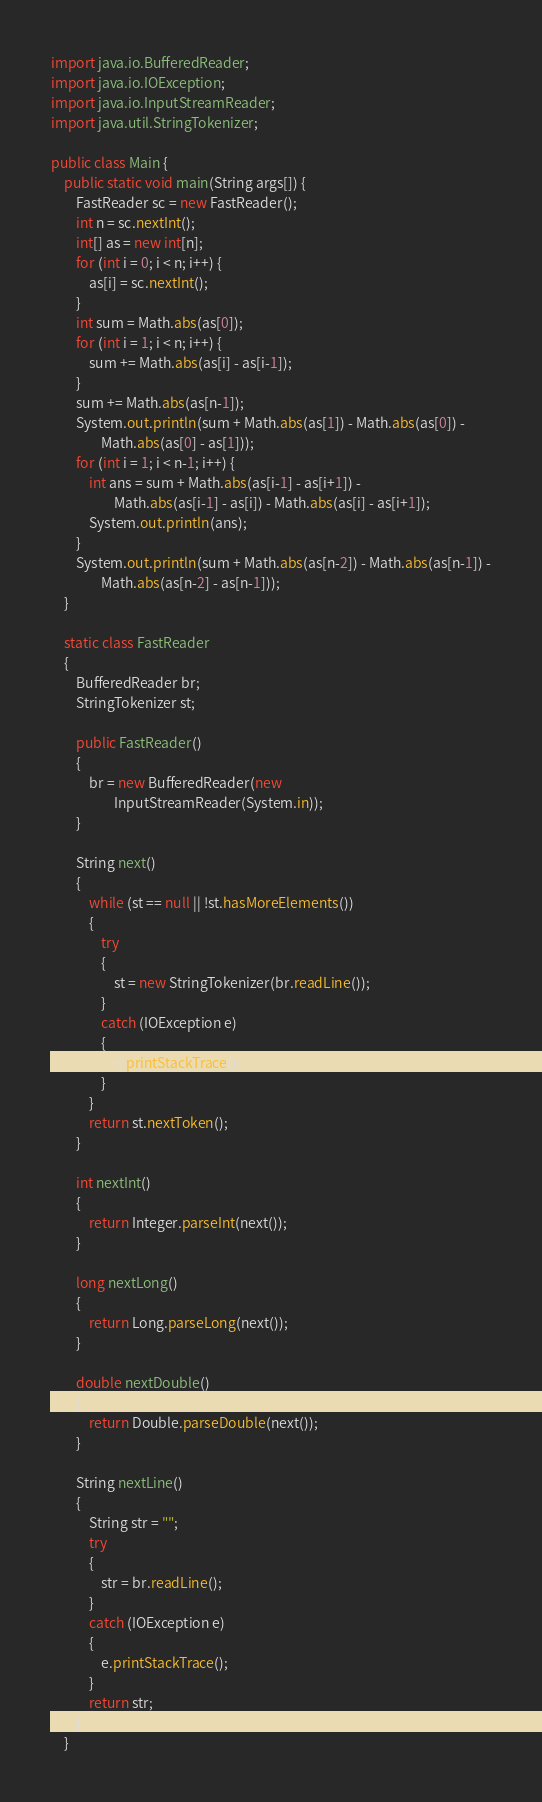Convert code to text. <code><loc_0><loc_0><loc_500><loc_500><_Java_>import java.io.BufferedReader;
import java.io.IOException;
import java.io.InputStreamReader;
import java.util.StringTokenizer;

public class Main {
    public static void main(String args[]) {
        FastReader sc = new FastReader();
        int n = sc.nextInt();
        int[] as = new int[n];
        for (int i = 0; i < n; i++) {
            as[i] = sc.nextInt();
        }
        int sum = Math.abs(as[0]);
        for (int i = 1; i < n; i++) {
            sum += Math.abs(as[i] - as[i-1]);
        }
        sum += Math.abs(as[n-1]);
        System.out.println(sum + Math.abs(as[1]) - Math.abs(as[0]) -
                Math.abs(as[0] - as[1]));
        for (int i = 1; i < n-1; i++) {
            int ans = sum + Math.abs(as[i-1] - as[i+1]) -
                    Math.abs(as[i-1] - as[i]) - Math.abs(as[i] - as[i+1]);
            System.out.println(ans);
        }
        System.out.println(sum + Math.abs(as[n-2]) - Math.abs(as[n-1]) -
                Math.abs(as[n-2] - as[n-1]));
    }

    static class FastReader
    {
        BufferedReader br;
        StringTokenizer st;

        public FastReader()
        {
            br = new BufferedReader(new
                    InputStreamReader(System.in));
        }

        String next()
        {
            while (st == null || !st.hasMoreElements())
            {
                try
                {
                    st = new StringTokenizer(br.readLine());
                }
                catch (IOException e)
                {
                    e.printStackTrace();
                }
            }
            return st.nextToken();
        }

        int nextInt()
        {
            return Integer.parseInt(next());
        }

        long nextLong()
        {
            return Long.parseLong(next());
        }

        double nextDouble()
        {
            return Double.parseDouble(next());
        }

        String nextLine()
        {
            String str = "";
            try
            {
                str = br.readLine();
            }
            catch (IOException e)
            {
                e.printStackTrace();
            }
            return str;
        }
    }</code> 